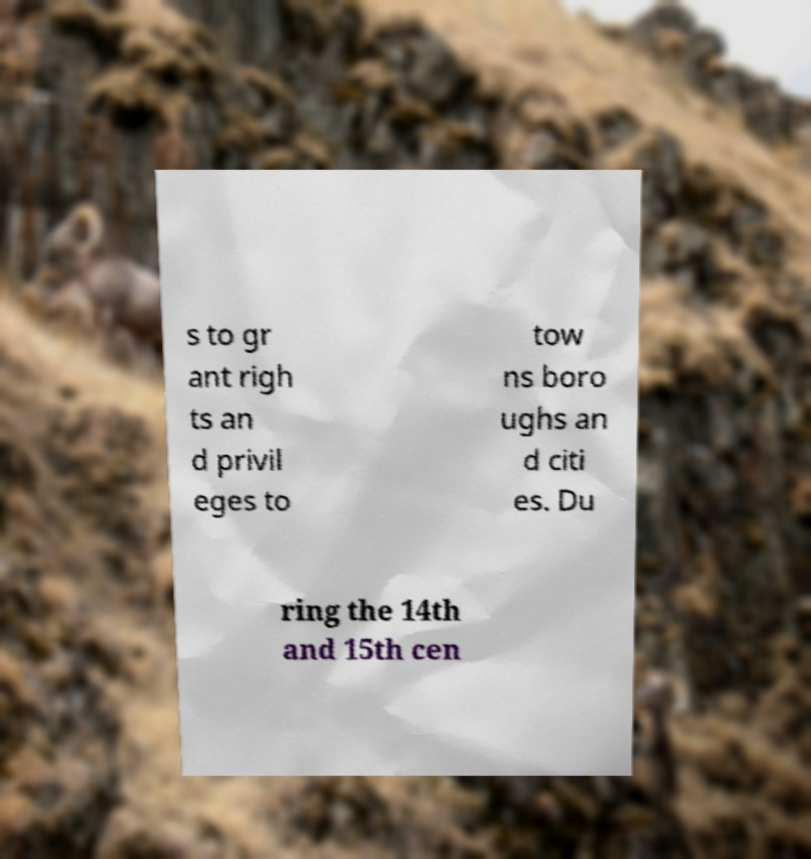Please read and relay the text visible in this image. What does it say? s to gr ant righ ts an d privil eges to tow ns boro ughs an d citi es. Du ring the 14th and 15th cen 